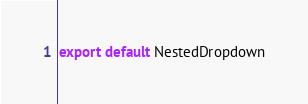<code> <loc_0><loc_0><loc_500><loc_500><_JavaScript_>export default NestedDropdown
</code> 